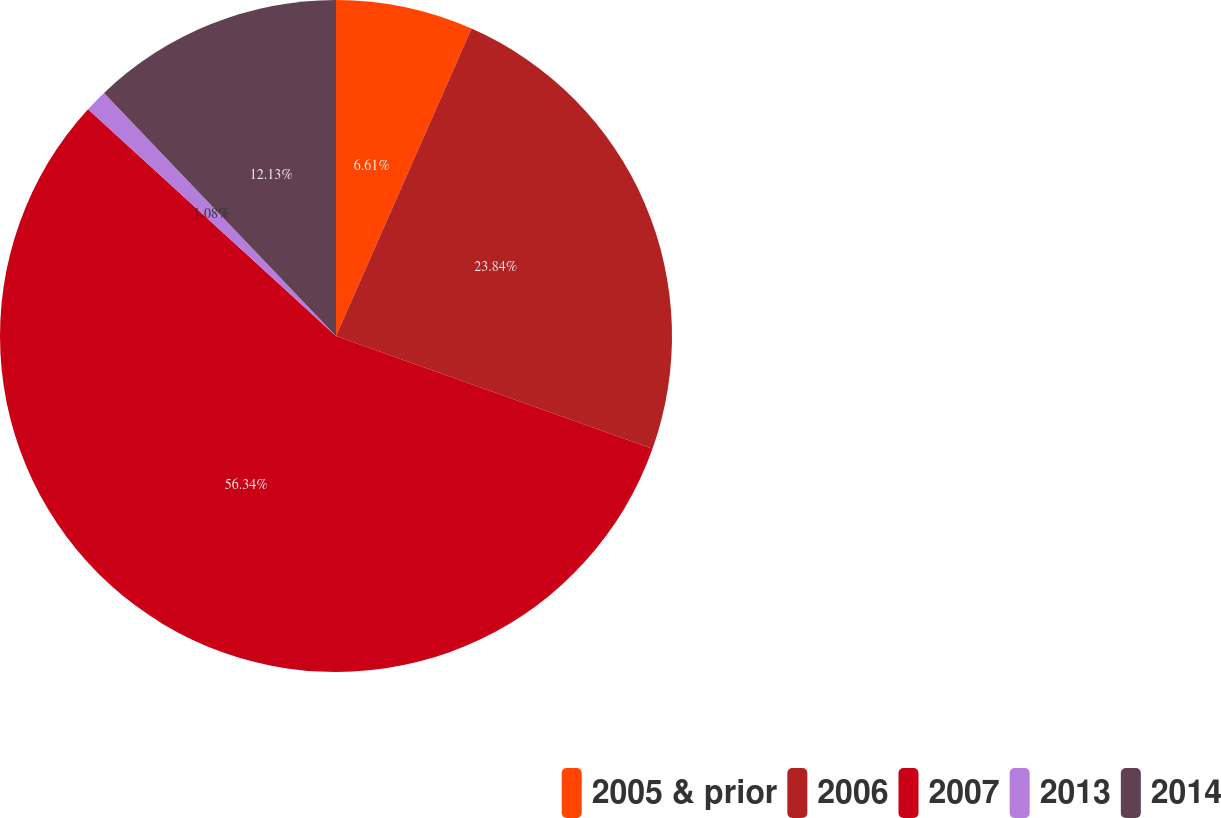<chart> <loc_0><loc_0><loc_500><loc_500><pie_chart><fcel>2005 & prior<fcel>2006<fcel>2007<fcel>2013<fcel>2014<nl><fcel>6.61%<fcel>23.84%<fcel>56.34%<fcel>1.08%<fcel>12.13%<nl></chart> 